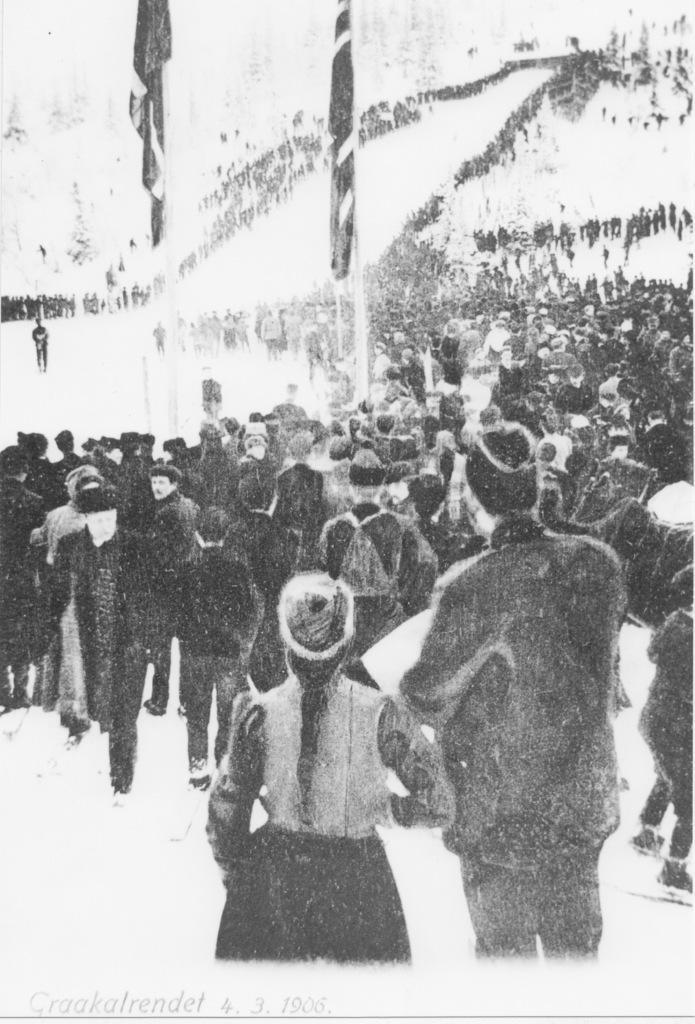Could you give a brief overview of what you see in this image? In this picture we can observe some people standing. There are two flags to the poles. There were men and women in this picture. This is a black and white picture. 